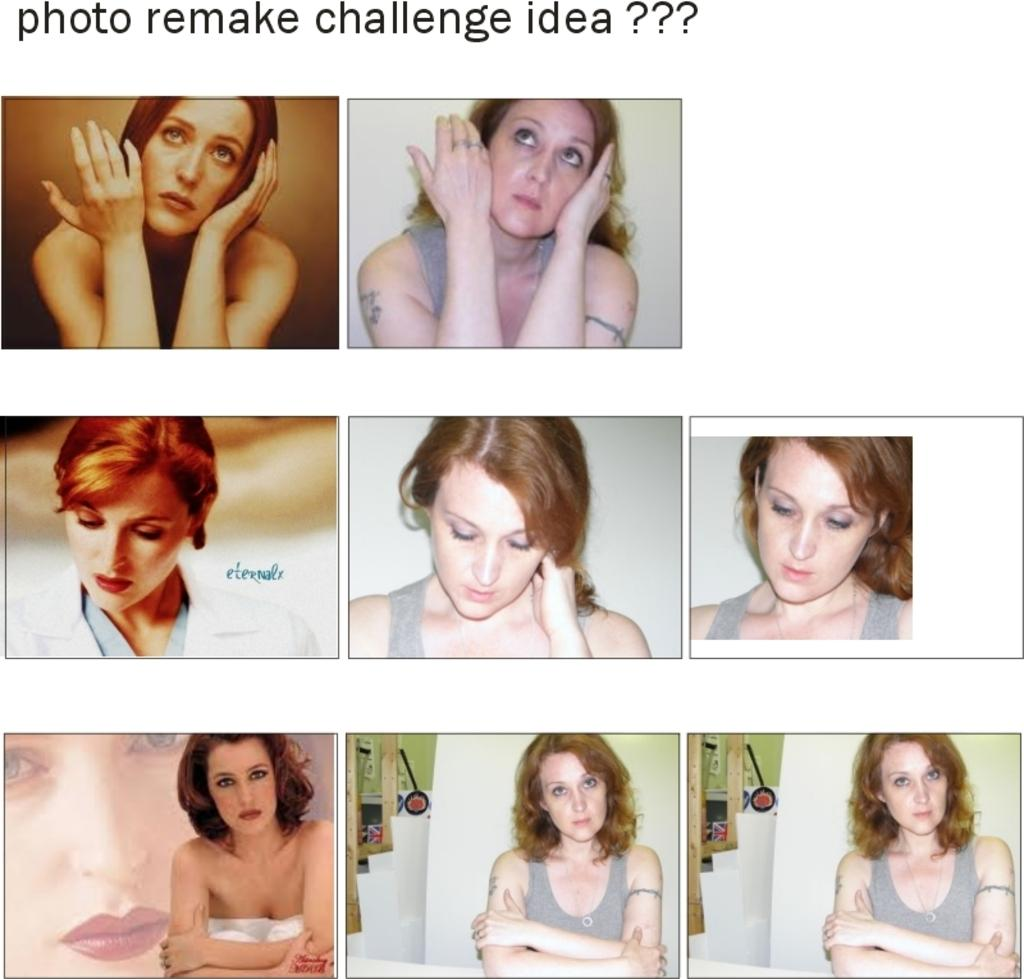What is the main subject of the photographs in the image? The main subject of the photographs in the image is a girl. Where are the photographs located in the image? The photographs are in the center of the image. What is written at the top side of the image? At the top side of the image, it is written "photo remake challenge idea." How many bats are hanging from the ceiling in the image? There are no bats present in the image. What type of apples are being used for the photo remake challenge idea? There are no apples mentioned or depicted in the image. 